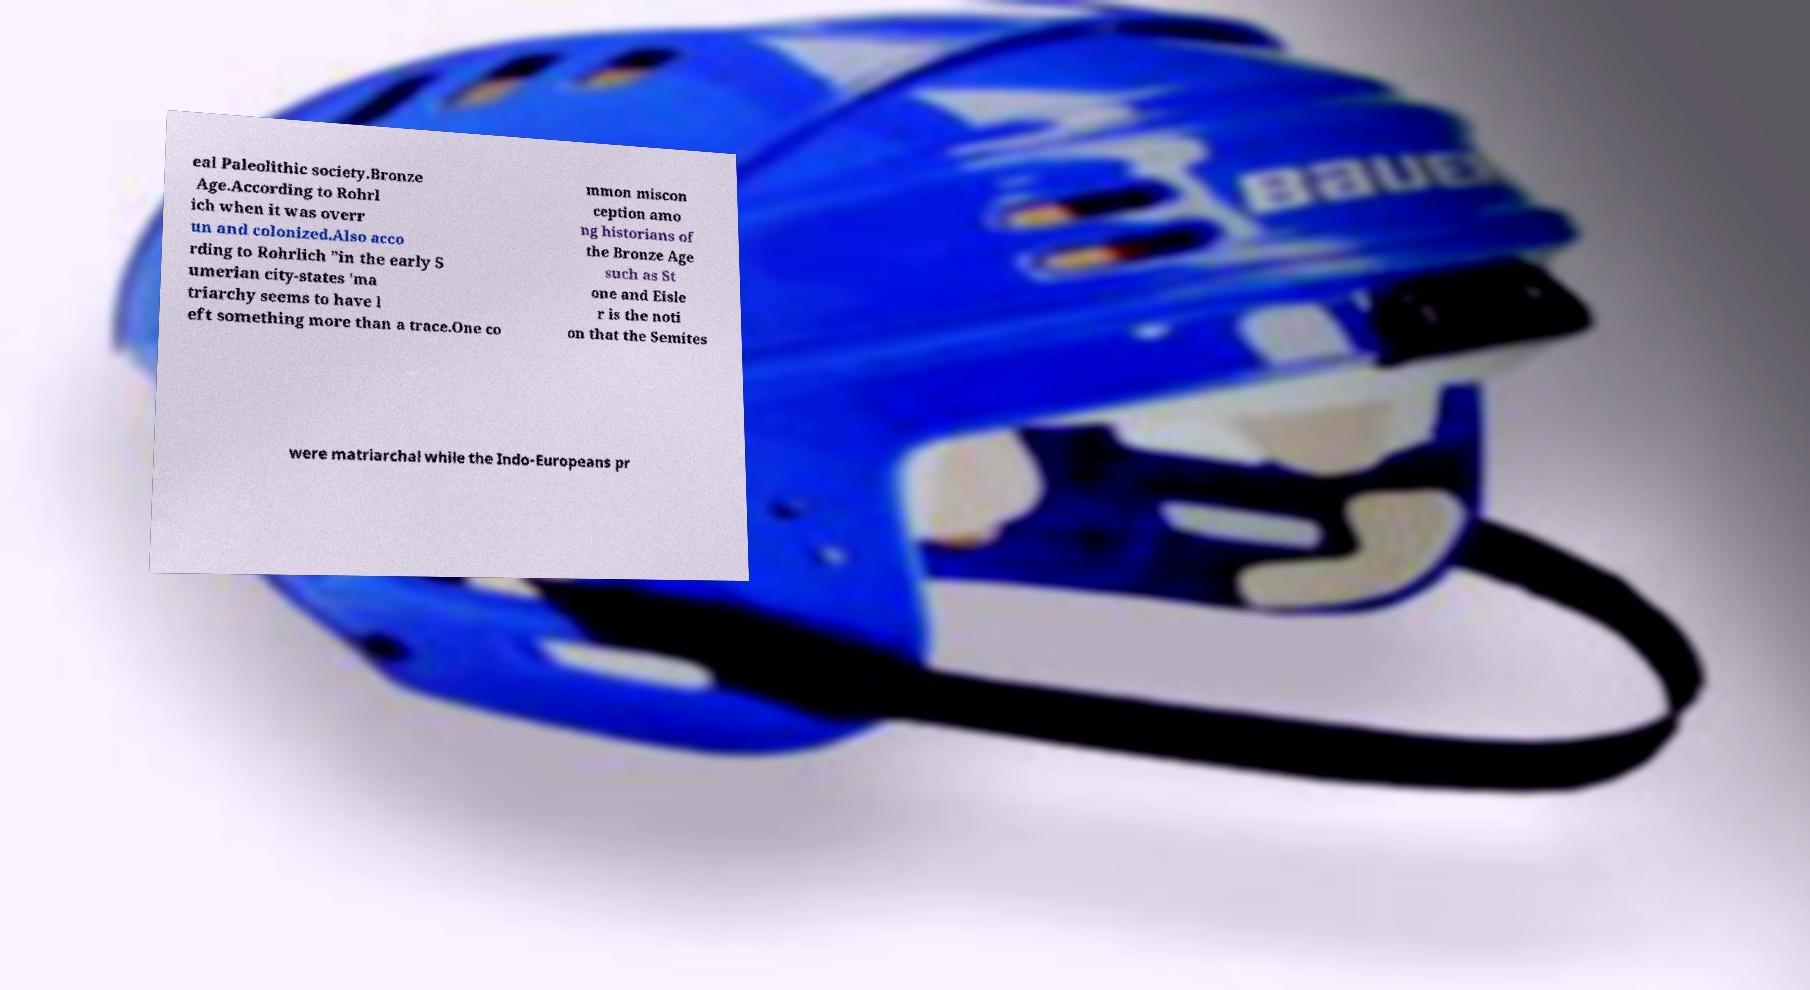Could you assist in decoding the text presented in this image and type it out clearly? eal Paleolithic society.Bronze Age.According to Rohrl ich when it was overr un and colonized.Also acco rding to Rohrlich "in the early S umerian city-states 'ma triarchy seems to have l eft something more than a trace.One co mmon miscon ception amo ng historians of the Bronze Age such as St one and Eisle r is the noti on that the Semites were matriarchal while the Indo-Europeans pr 